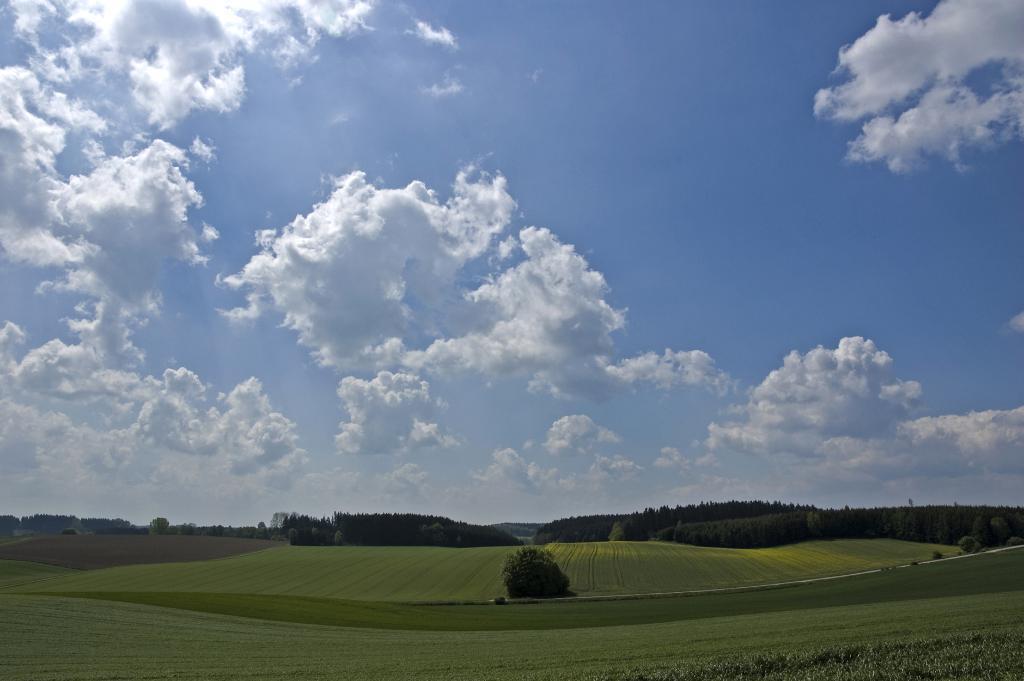Please provide a concise description of this image. In this picture we can see some grass on the ground. There are a few plants visible on the grass. We can see some trees in the background. Sky is blue in color and cloudy. 